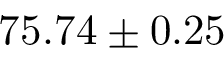<formula> <loc_0><loc_0><loc_500><loc_500>7 5 . 7 4 \pm 0 . 2 5</formula> 